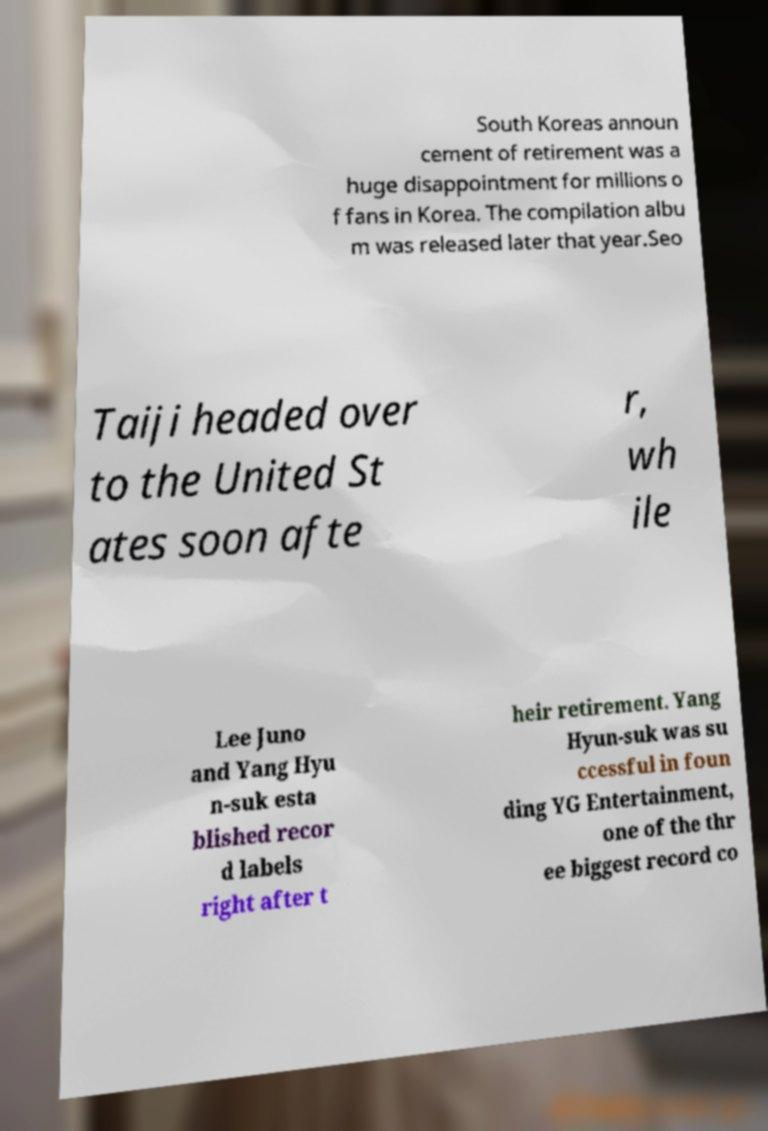Please identify and transcribe the text found in this image. South Koreas announ cement of retirement was a huge disappointment for millions o f fans in Korea. The compilation albu m was released later that year.Seo Taiji headed over to the United St ates soon afte r, wh ile Lee Juno and Yang Hyu n-suk esta blished recor d labels right after t heir retirement. Yang Hyun-suk was su ccessful in foun ding YG Entertainment, one of the thr ee biggest record co 